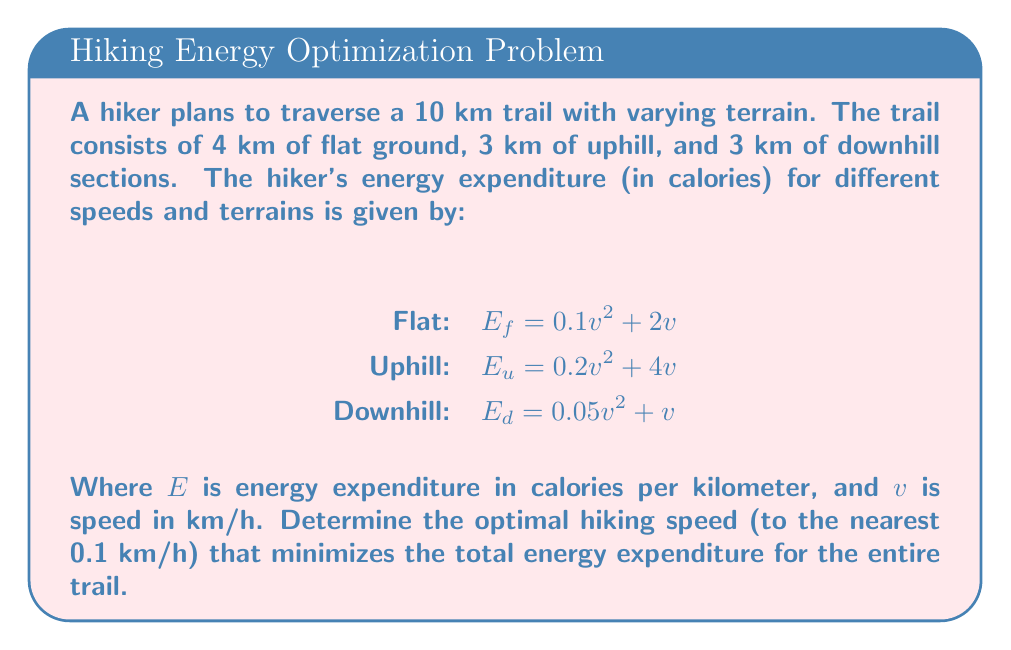Could you help me with this problem? To solve this problem, we'll follow these steps:

1) First, let's express the total energy expenditure as a function of speed:

   $E_{total} = 4E_f + 3E_u + 3E_d$

2) Substitute the given equations:

   $E_{total} = 4(0.1v^2 + 2v) + 3(0.2v^2 + 4v) + 3(0.05v^2 + v)$

3) Simplify:

   $E_{total} = (0.4 + 0.6 + 0.15)v^2 + (8 + 12 + 3)v$
   $E_{total} = 1.15v^2 + 23v$

4) To find the minimum of this function, we need to differentiate it with respect to v and set it to zero:

   $\frac{dE_{total}}{dv} = 2.3v + 23 = 0$

5) Solve for v:

   $2.3v = -23$
   $v = -10$

6) Since negative speed doesn't make sense in this context, we need to find the minimum positive value. This occurs at the lowest point of the parabola, which is at the axis of symmetry:

   $v = \frac{-23}{2.3} = 10$ km/h

7) To verify this is a minimum, we can check the second derivative:

   $\frac{d^2E_{total}}{dv^2} = 2.3 > 0$

   This confirms it's a minimum.

8) Rounding to the nearest 0.1 km/h:

   $v_{optimal} = 10.0$ km/h
Answer: 10.0 km/h 